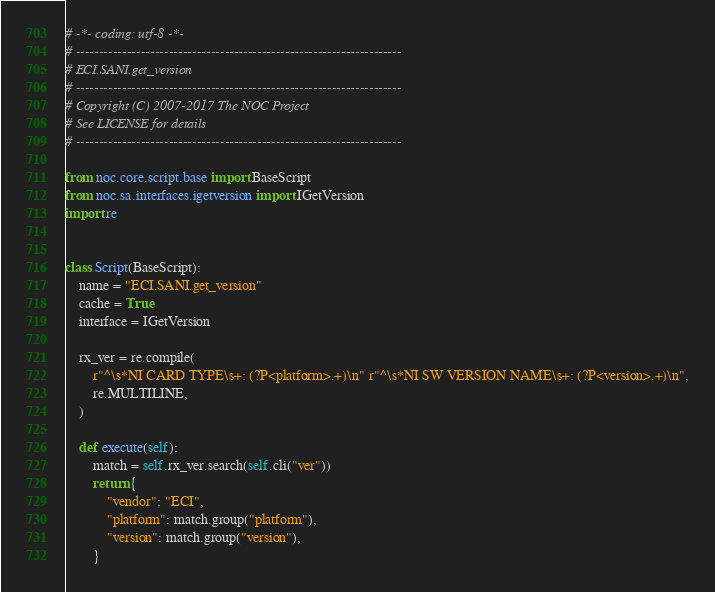Convert code to text. <code><loc_0><loc_0><loc_500><loc_500><_Python_># -*- coding: utf-8 -*-
# ----------------------------------------------------------------------
# ECI.SANI.get_version
# ----------------------------------------------------------------------
# Copyright (C) 2007-2017 The NOC Project
# See LICENSE for details
# ----------------------------------------------------------------------

from noc.core.script.base import BaseScript
from noc.sa.interfaces.igetversion import IGetVersion
import re


class Script(BaseScript):
    name = "ECI.SANI.get_version"
    cache = True
    interface = IGetVersion

    rx_ver = re.compile(
        r"^\s*NI CARD TYPE\s+: (?P<platform>.+)\n" r"^\s*NI SW VERSION NAME\s+: (?P<version>.+)\n",
        re.MULTILINE,
    )

    def execute(self):
        match = self.rx_ver.search(self.cli("ver"))
        return {
            "vendor": "ECI",
            "platform": match.group("platform"),
            "version": match.group("version"),
        }
</code> 